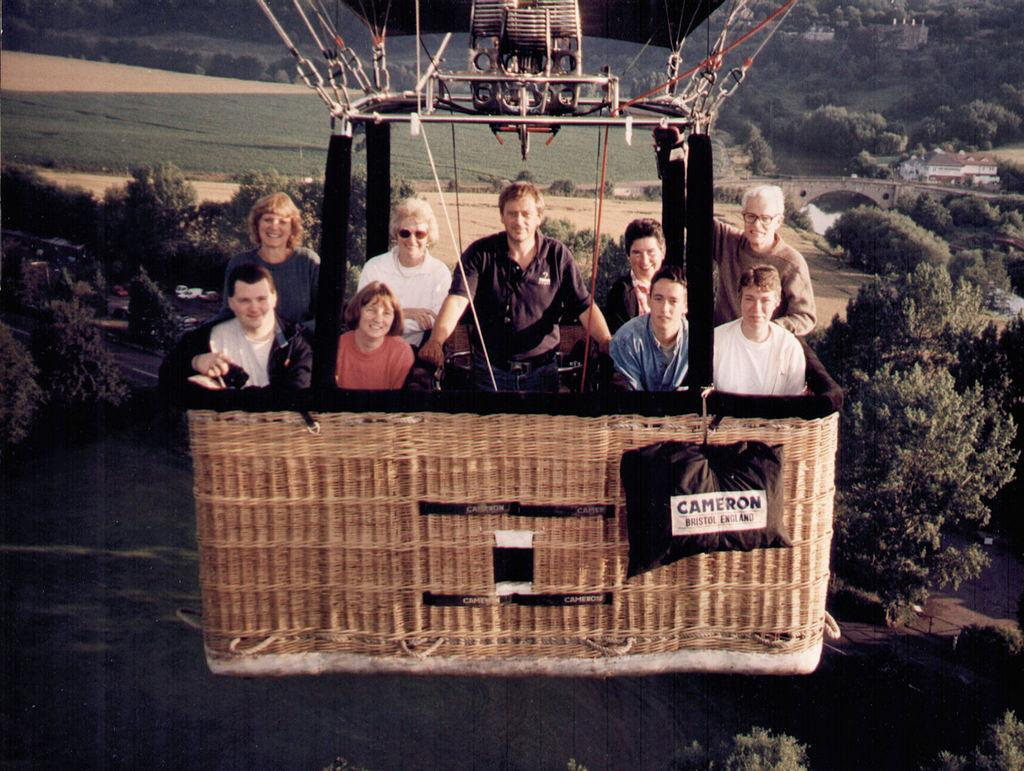What are the people in the image doing? The people in the ropeway are smiling. What can be seen on either side of the ropeway? There are trees on either side of the ropeway. What is visible in the background of the image? There are trees and hills in the background of the image. How far away is the robin from the ropeway in the image? There is no robin present in the image. Is the person in the ropeway wearing a veil? There is no indication of a veil being worn by anyone in the image. 